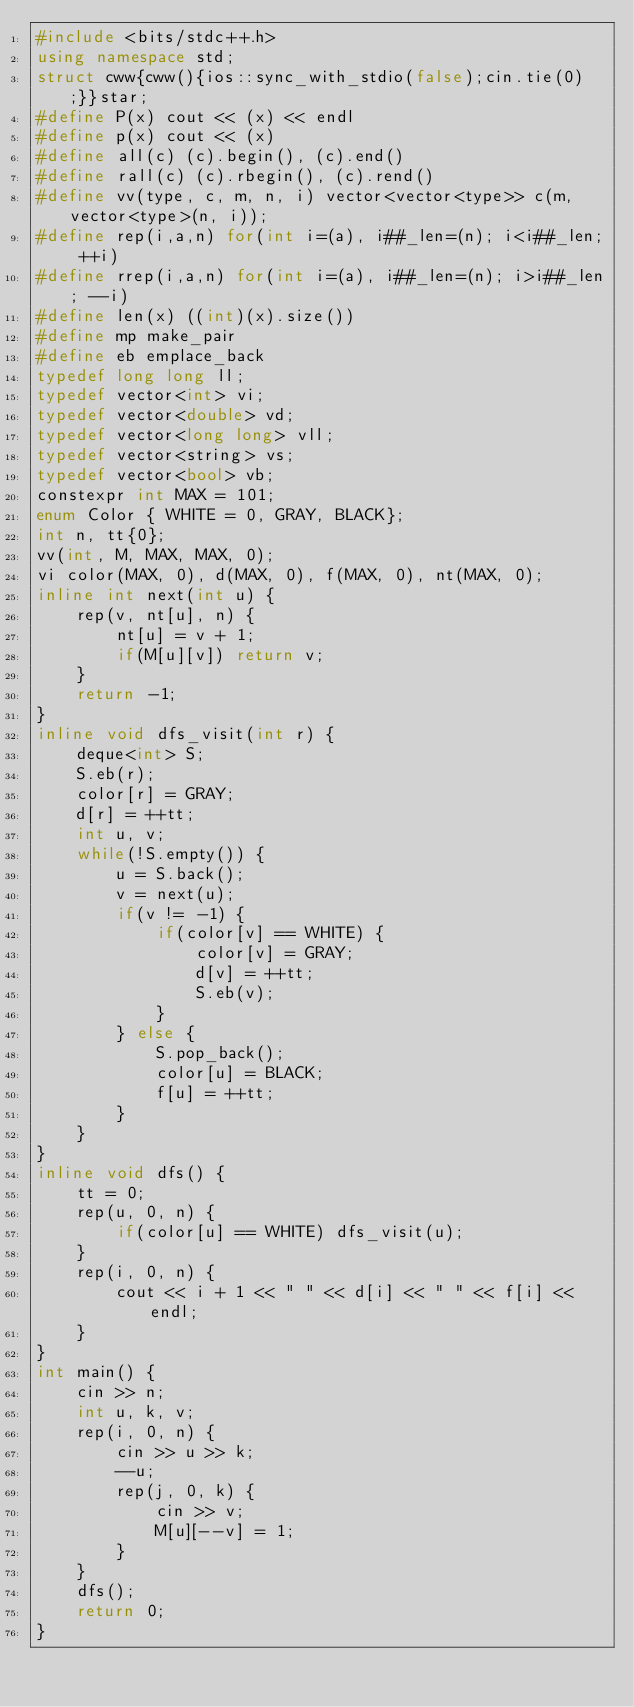<code> <loc_0><loc_0><loc_500><loc_500><_C++_>#include <bits/stdc++.h>
using namespace std;
struct cww{cww(){ios::sync_with_stdio(false);cin.tie(0);}}star;
#define P(x) cout << (x) << endl
#define p(x) cout << (x)
#define all(c) (c).begin(), (c).end()
#define rall(c) (c).rbegin(), (c).rend()
#define vv(type, c, m, n, i) vector<vector<type>> c(m, vector<type>(n, i));
#define rep(i,a,n) for(int i=(a), i##_len=(n); i<i##_len; ++i)
#define rrep(i,a,n) for(int i=(a), i##_len=(n); i>i##_len; --i)
#define len(x) ((int)(x).size())
#define mp make_pair
#define eb emplace_back
typedef long long ll;
typedef vector<int> vi;
typedef vector<double> vd;
typedef vector<long long> vll;
typedef vector<string> vs;
typedef vector<bool> vb;
constexpr int MAX = 101;
enum Color { WHITE = 0, GRAY, BLACK};
int n, tt{0};
vv(int, M, MAX, MAX, 0);
vi color(MAX, 0), d(MAX, 0), f(MAX, 0), nt(MAX, 0);
inline int next(int u) {
	rep(v, nt[u], n) {
		nt[u] = v + 1;
		if(M[u][v]) return v;
	}
	return -1;
}
inline void dfs_visit(int r) {
	deque<int> S;
	S.eb(r);
	color[r] = GRAY;
	d[r] = ++tt;
	int u, v;
	while(!S.empty()) {
		u = S.back();
		v = next(u);
		if(v != -1) {
			if(color[v] == WHITE) {
				color[v] = GRAY;
				d[v] = ++tt;
				S.eb(v);
			}
		} else {
			S.pop_back();
			color[u] = BLACK;
			f[u] = ++tt;
		}
	}
}
inline void dfs() {
	tt = 0;
	rep(u, 0, n) {
		if(color[u] == WHITE) dfs_visit(u);
	}
	rep(i, 0, n) {
		cout << i + 1 << " " << d[i] << " " << f[i] << endl;
	}
}
int main() {
	cin >> n;
	int u, k, v;
	rep(i, 0, n) {
		cin >> u >> k;
		--u;
		rep(j, 0, k) {
			cin >> v;
			M[u][--v] = 1;
		}
	}
	dfs();
	return 0;
}</code> 